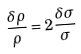Convert formula to latex. <formula><loc_0><loc_0><loc_500><loc_500>\frac { { \delta } { \rho } } { \rho } = 2 \frac { { \delta } { \sigma } } { \sigma }</formula> 